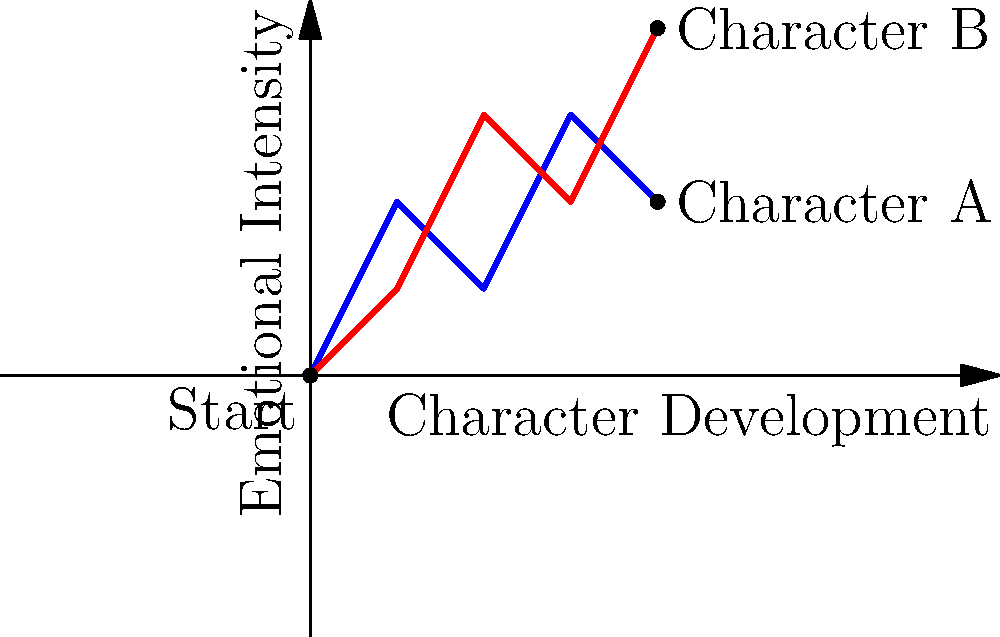In a 2D grid representing character journeys, where the x-axis shows character development and the y-axis shows emotional intensity, two characters' story arcs are plotted. Character A's journey is represented by the blue line, while Character B's journey is shown in red. Based on the graph, which character experiences a higher emotional intensity at the end of their arc, and what is the difference in their final emotional intensities? To answer this question, we need to follow these steps:

1. Identify the end points of both character arcs:
   - Character A (blue line) ends at coordinates (4, 2)
   - Character B (red line) ends at coordinates (4, 4)

2. Compare the y-coordinates (emotional intensity) of the end points:
   - Character A's final emotional intensity: 2
   - Character B's final emotional intensity: 4

3. Determine which character has a higher final emotional intensity:
   - Character B has a higher y-coordinate (4 > 2), so Character B experiences a higher emotional intensity at the end of their arc.

4. Calculate the difference in final emotional intensities:
   - Difference = Character B's intensity - Character A's intensity
   - Difference = 4 - 2 = 2

Therefore, Character B experiences a higher emotional intensity at the end of their arc, and the difference in their final emotional intensities is 2 units.
Answer: Character B; 2 units 